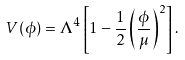<formula> <loc_0><loc_0><loc_500><loc_500>V ( \phi ) = \Lambda ^ { 4 } \left [ 1 - \frac { 1 } { 2 } \left ( \frac { \phi } { \mu } \right ) ^ { 2 } \right ] .</formula> 